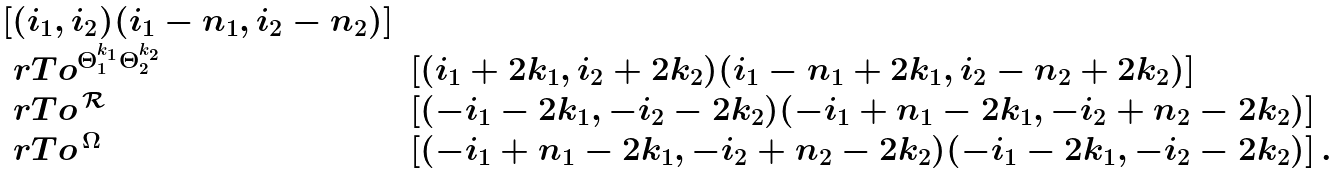<formula> <loc_0><loc_0><loc_500><loc_500>\begin{array} { l l } { [ ( i _ { 1 } , i _ { 2 } ) ( i _ { 1 } - n _ { 1 } , i _ { 2 } - n _ { 2 } ) ] } & \\ \ r T o ^ { \Theta _ { 1 } ^ { k _ { 1 } } \Theta _ { 2 } ^ { k _ { 2 } } } & [ ( i _ { 1 } + 2 k _ { 1 } , i _ { 2 } + 2 k _ { 2 } ) ( i _ { 1 } - n _ { 1 } + 2 k _ { 1 } , i _ { 2 } - n _ { 2 } + 2 k _ { 2 } ) ] \\ \ r T o ^ { \, \mathcal { R } \, } & [ ( - i _ { 1 } - 2 k _ { 1 } , - i _ { 2 } - 2 k _ { 2 } ) ( - i _ { 1 } + n _ { 1 } - 2 k _ { 1 } , - i _ { 2 } + n _ { 2 } - 2 k _ { 2 } ) ] \\ \ r T o ^ { \, \Omega \, } & [ ( - i _ { 1 } + n _ { 1 } - 2 k _ { 1 } , - i _ { 2 } + n _ { 2 } - 2 k _ { 2 } ) ( - i _ { 1 } - 2 k _ { 1 } , - i _ { 2 } - 2 k _ { 2 } ) ] \, . \end{array}</formula> 